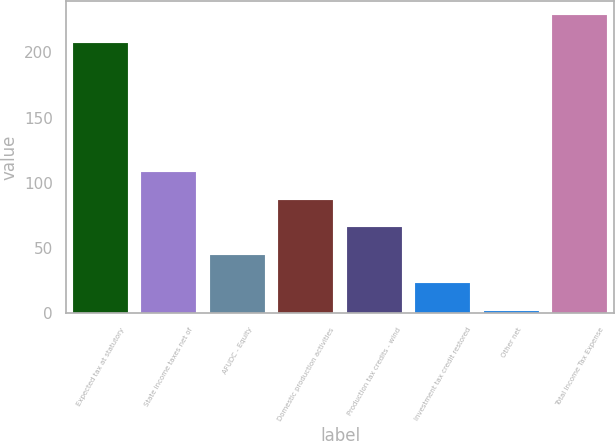Convert chart to OTSL. <chart><loc_0><loc_0><loc_500><loc_500><bar_chart><fcel>Expected tax at statutory<fcel>State income taxes net of<fcel>AFUDC - Equity<fcel>Domestic production activities<fcel>Production tax credits - wind<fcel>Investment tax credit restored<fcel>Other net<fcel>Total Income Tax Expense<nl><fcel>206.9<fcel>108.55<fcel>44.38<fcel>87.16<fcel>65.77<fcel>22.99<fcel>1.6<fcel>228.29<nl></chart> 